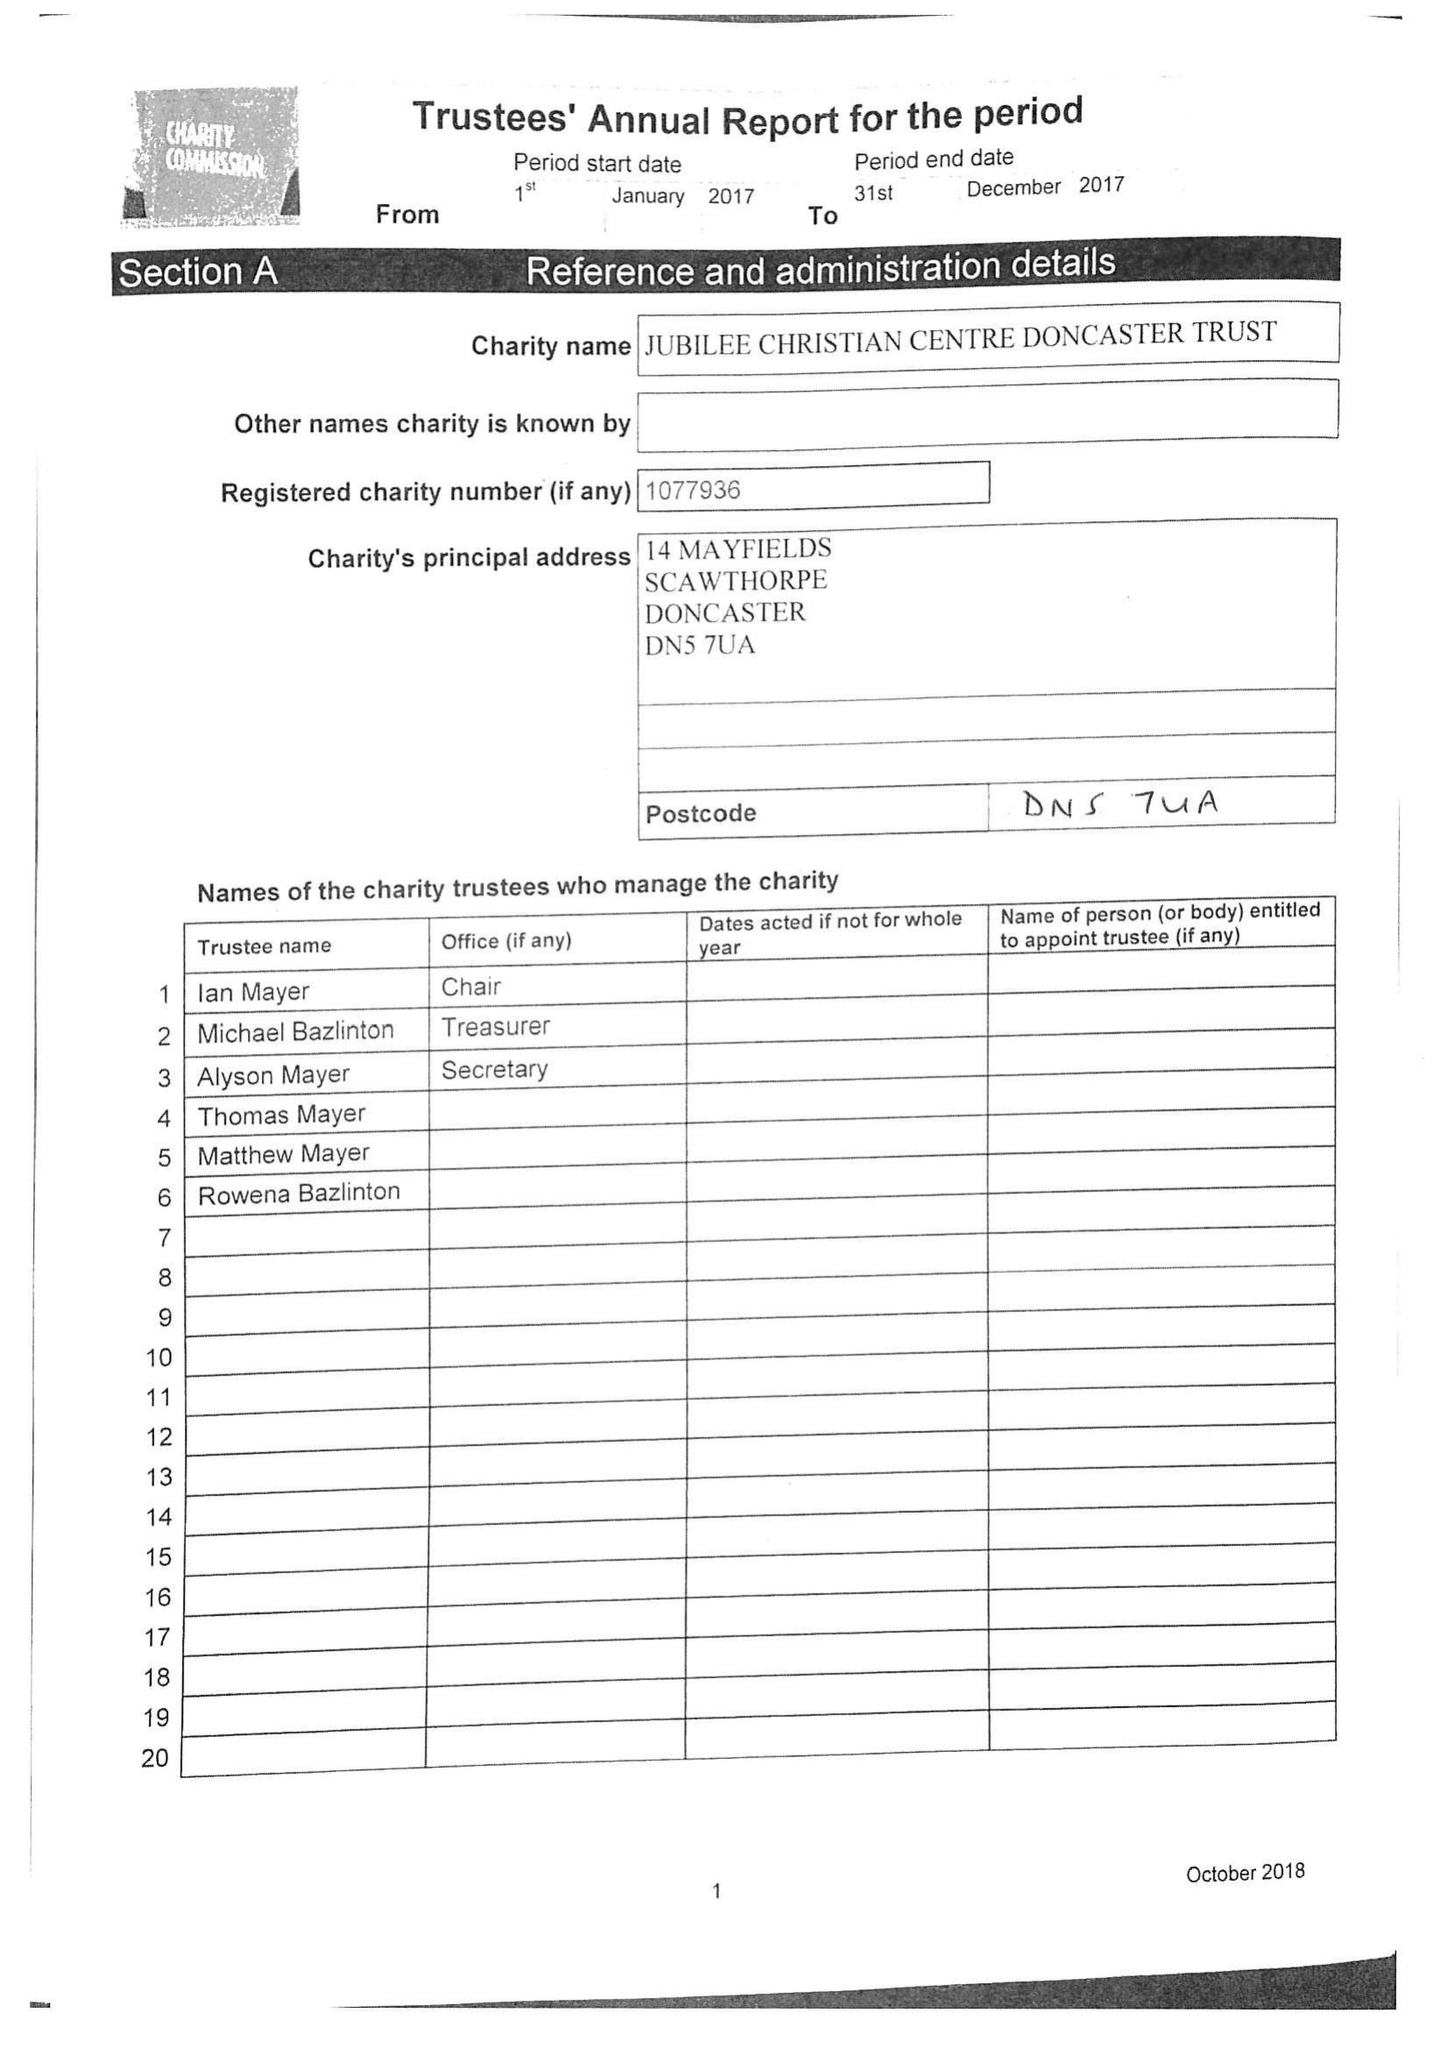What is the value for the report_date?
Answer the question using a single word or phrase. 2017-12-31 